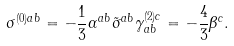<formula> <loc_0><loc_0><loc_500><loc_500>\sigma ^ { ( 0 ) a b } = - \frac { 1 } { 3 } \alpha ^ { a b } \tilde { \sigma } ^ { a b } \gamma _ { a b } ^ { ( 2 ) c } = - \frac { 4 } { 3 } \beta ^ { c } .</formula> 